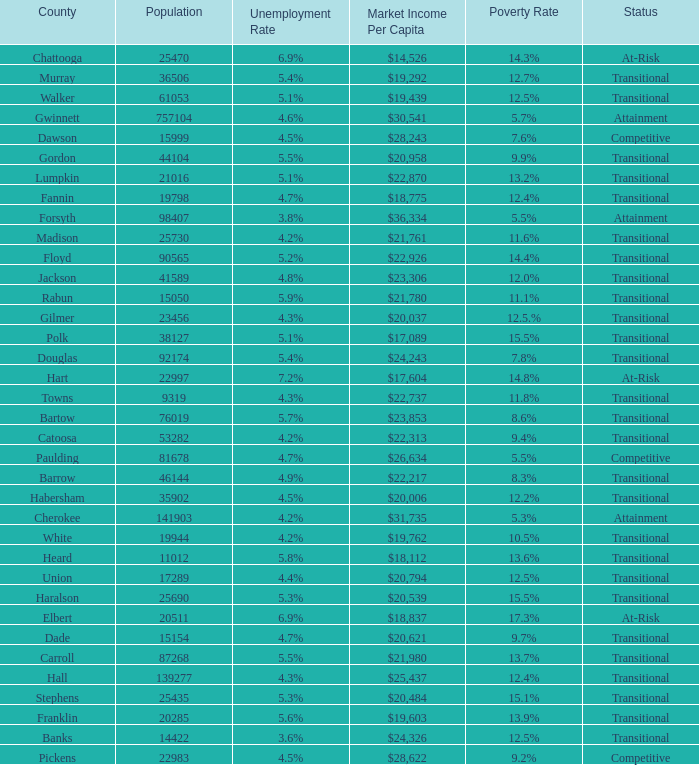What is the status of the county with per capita market income of $24,326? Transitional. 